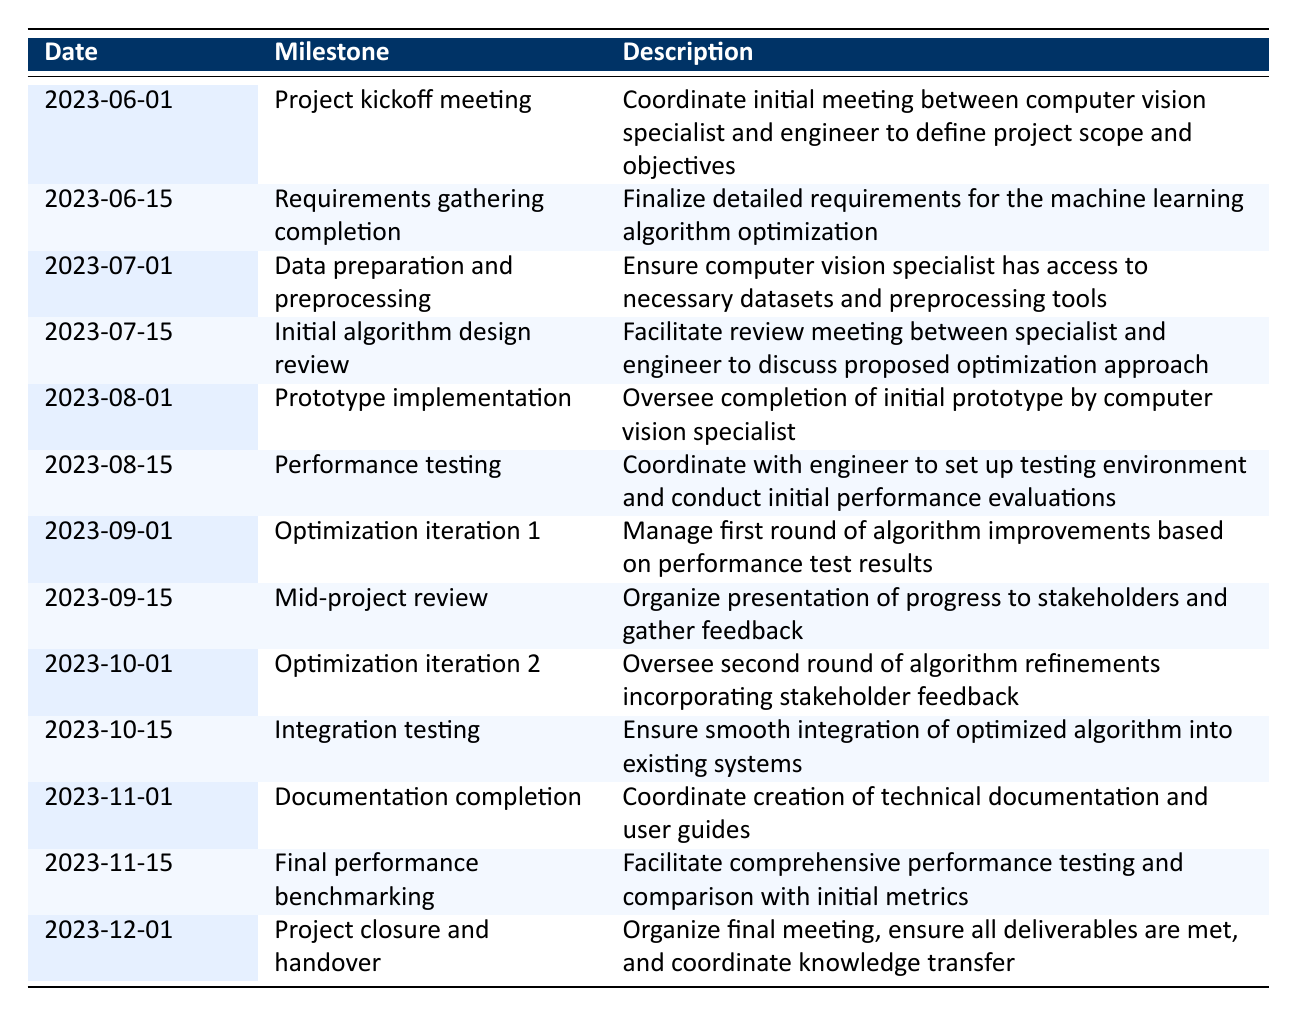What is the date of the project kickoff meeting? The project kickoff meeting is listed under the milestone with the date 2023-06-01.
Answer: 2023-06-01 What is the milestone corresponding to the date 2023-10-01? The milestone on 2023-10-01 is "Optimization iteration 2."
Answer: Optimization iteration 2 How many optimization iterations are scheduled in the timeline? There are two optimization iterations detailed in the timeline: "Optimization iteration 1" on 2023-09-01 and "Optimization iteration 2" on 2023-10-01.
Answer: 2 Is there a milestone for performance testing before the project mid-review? Yes, "Performance testing" is scheduled on 2023-08-15, which is before the "Mid-project review" on 2023-09-15.
Answer: Yes What is the time gap between the "Final performance benchmarking" and the "Project closure and handover"? "Final performance benchmarking" is on 2023-11-15 and "Project closure and handover" is on 2023-12-01. The gap is 16 days.
Answer: 16 days What percentage of the overall timeline is dedicated to testing phases (including performance and integration testing)? The testing phases are "Performance testing" on 2023-08-15 and "Integration testing" on 2023-10-15, which are two milestones in a total of 13. The percentage is (2/13) * 100 ≈ 15.38%.
Answer: Approximately 15.38% How many weeks are there from the initial algorithm design review to the integration testing? "Initial algorithm design review" is on 2023-07-15 and "Integration testing" is on 2023-10-15. There are 13 weeks between these two dates.
Answer: 13 weeks Which milestone occurs immediately after the prototype implementation? After "Prototype implementation" on 2023-08-01, the next milestone is "Performance testing" on 2023-08-15.
Answer: Performance testing What is the final milestone in the timeline, and what does it entail? The final milestone is "Project closure and handover" on 2023-12-01, which involves organizing a final meeting, ensuring all deliverables are met, and coordinating knowledge transfer.
Answer: Project closure and handover 